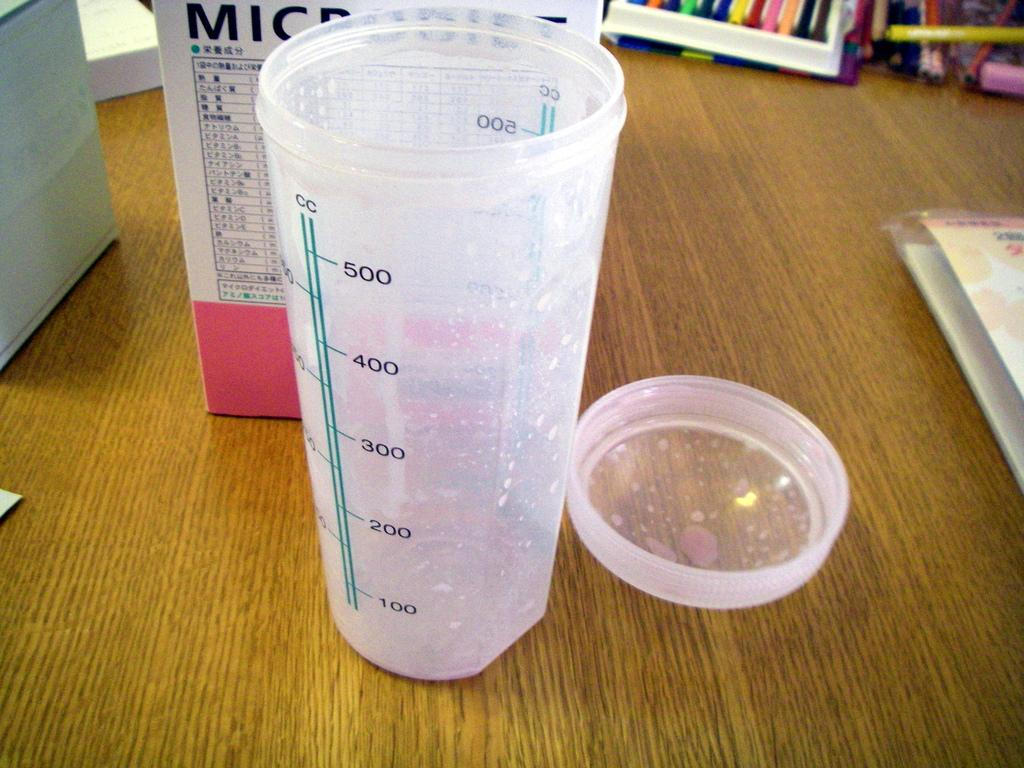<image>
Share a concise interpretation of the image provided. An empty container is designed to hold up to 500 ccs. 